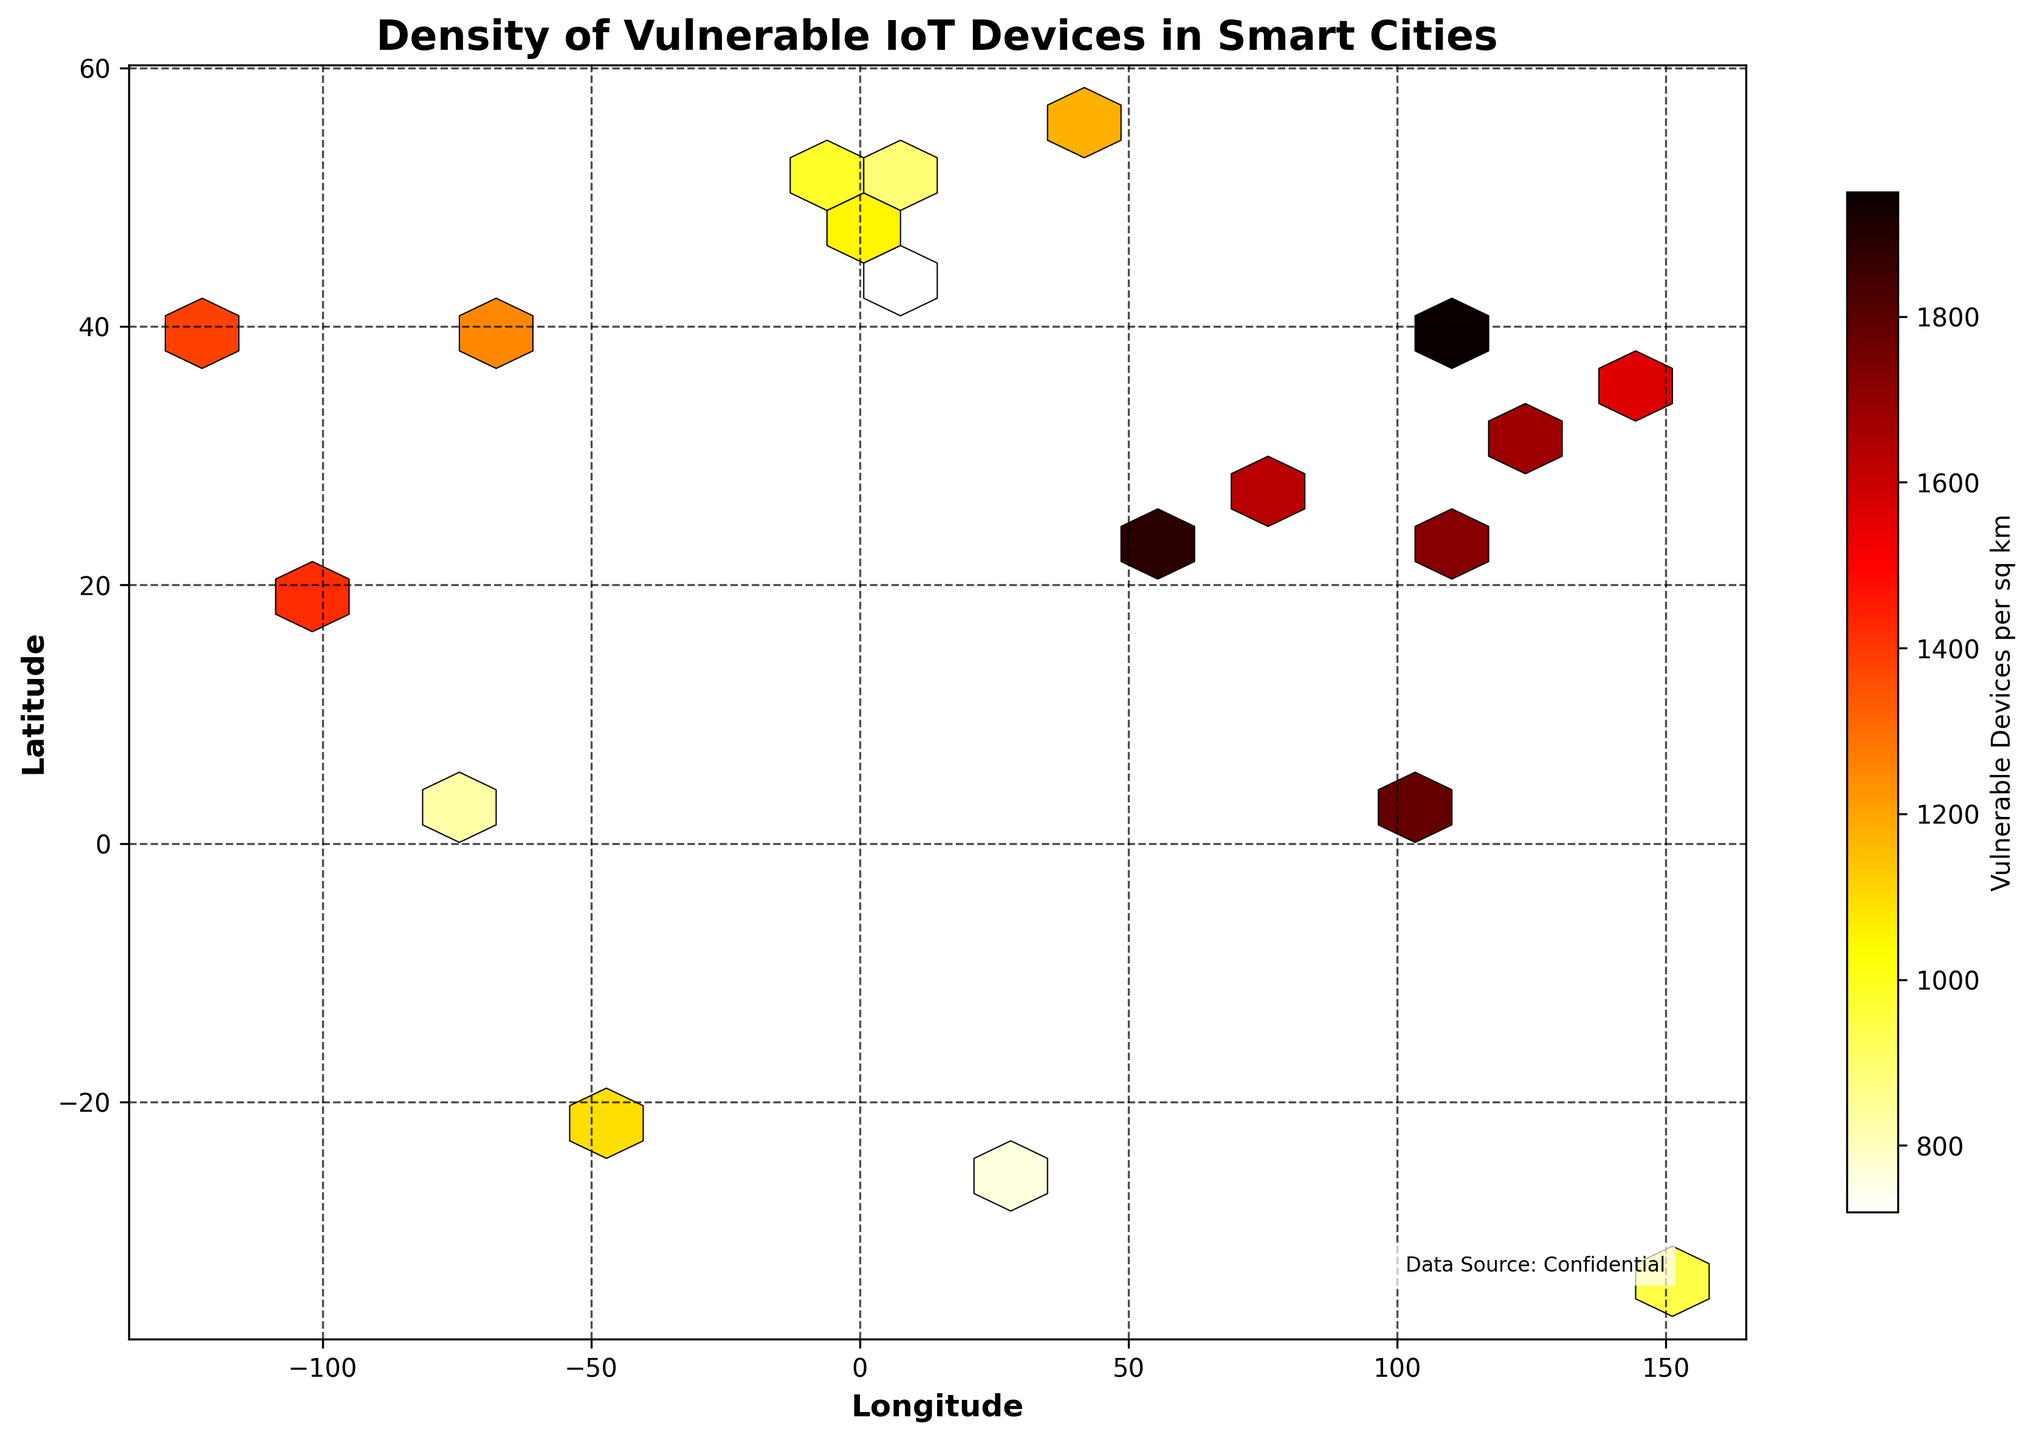What is the title of the plot? The title is usually found at the top of the plot. In this case, it reads "Density of Vulnerable IoT Devices in Smart Cities".
Answer: Density of Vulnerable IoT Devices in Smart Cities What do the colors in the hexbin plot represent? The color intensity in the hexbin plot represents the density of vulnerable IoT devices per square kilometer. The color bar titled "Vulnerable Devices per sq km" indicates this.
Answer: Density of vulnerable IoT devices What are the x-axis and y-axis labels? The labels on the axes define what each axis represents. The x-axis is labeled "Longitude," and the y-axis is labeled "Latitude".
Answer: Longitude, Latitude Which city has the highest density of vulnerable IoT devices per square kilometer? By checking the data in combination with the plot, we see Singapore (1.3521, 103.8198) has the highest density of 2100 devices per square kilometer.
Answer: Singapore Are there any cities with more than 1500 vulnerable IoT devices per square kilometer? We need to check the color intensity and the color bar, or refer to data points that have values over 1500. From the data, Tokyo, Hong Kong, Dubai, Shanghai, Beijing, and New Delhi are cities with more than 1500 vulnerable IoT devices per square kilometer.
Answer: Yes Which city has approximately 1380 vulnerable IoT devices per square kilometer, and what are its coordinates? Checking the data, we find that San Francisco (37.7749, -122.4194) has approximately 1380 vulnerable IoT devices per square kilometer.
Answer: San Francisco (37.7749, -122.4194) How does the density of vulnerable devices in Paris compare to that in Moscow? From the data, Paris has 1050 devices per square kilometer, while Moscow has 1180 devices per square kilometer. Therefore, Moscow has a higher density than Paris.
Answer: Moscow has higher density What is the range of vulnerable devices per square kilometer shown in the color bar? Observing the color bar on the right side of the plot, the range goes from the lowest color indication around 720 up to the highest at 2100 devices per square kilometer.
Answer: 720 to 2100 How many cities have less than 1000 vulnerable devices per square kilometer? We need to count the points in the data with values below 1000. Cities are London, Berlin, Rome, Sydney, Sao Paulo, and Johannesburg— a total of 6 cities.
Answer: 6 What is the primary geographical trend of vulnerable IoT device densities seen in the plot? The plot shows denser concentrations (darker colors) at specific longitudes and latitudes. Higher densities are observed in major cities across Asia (e.g., Tokyo, Hong Kong, Singapore), while lower densities are distributed more sparsely.
Answer: Higher densities in major Asian cities 